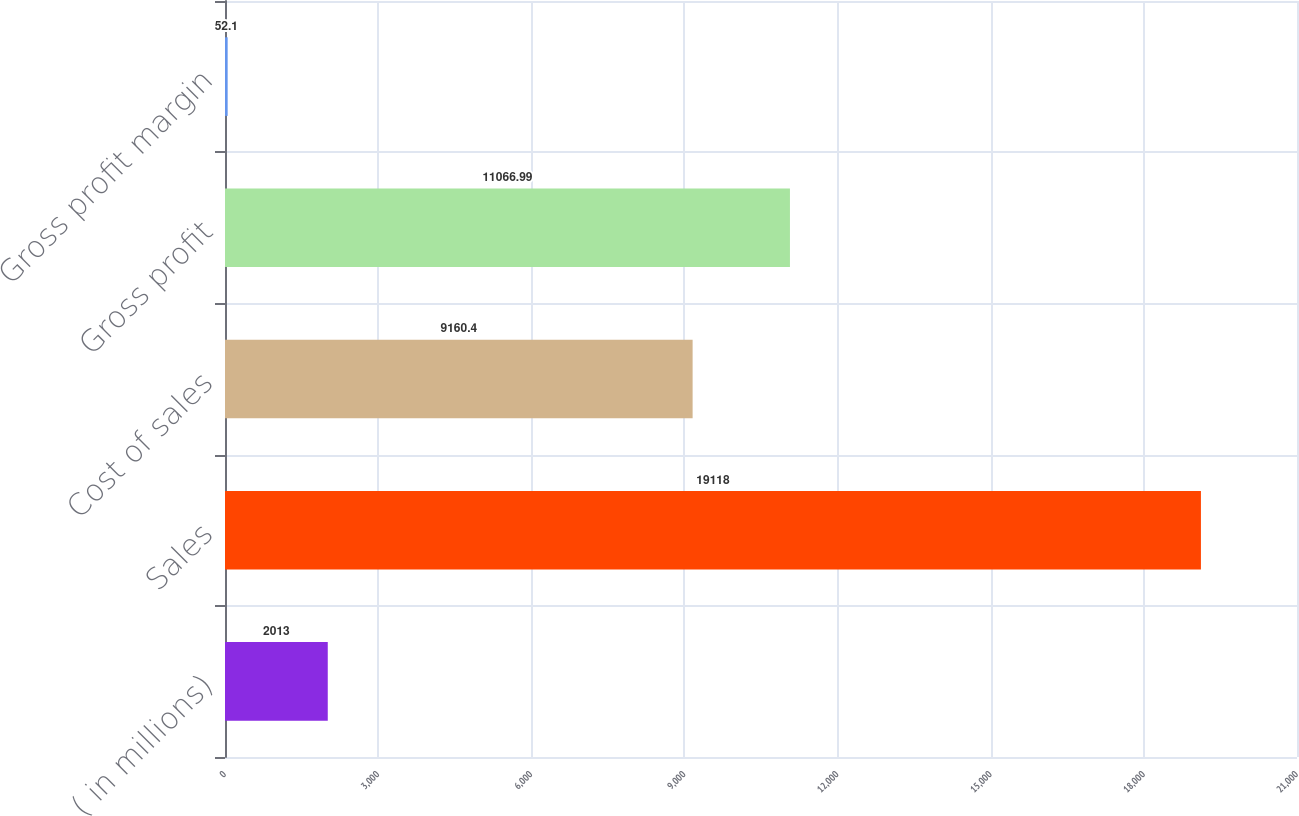<chart> <loc_0><loc_0><loc_500><loc_500><bar_chart><fcel>( in millions)<fcel>Sales<fcel>Cost of sales<fcel>Gross profit<fcel>Gross profit margin<nl><fcel>2013<fcel>19118<fcel>9160.4<fcel>11067<fcel>52.1<nl></chart> 